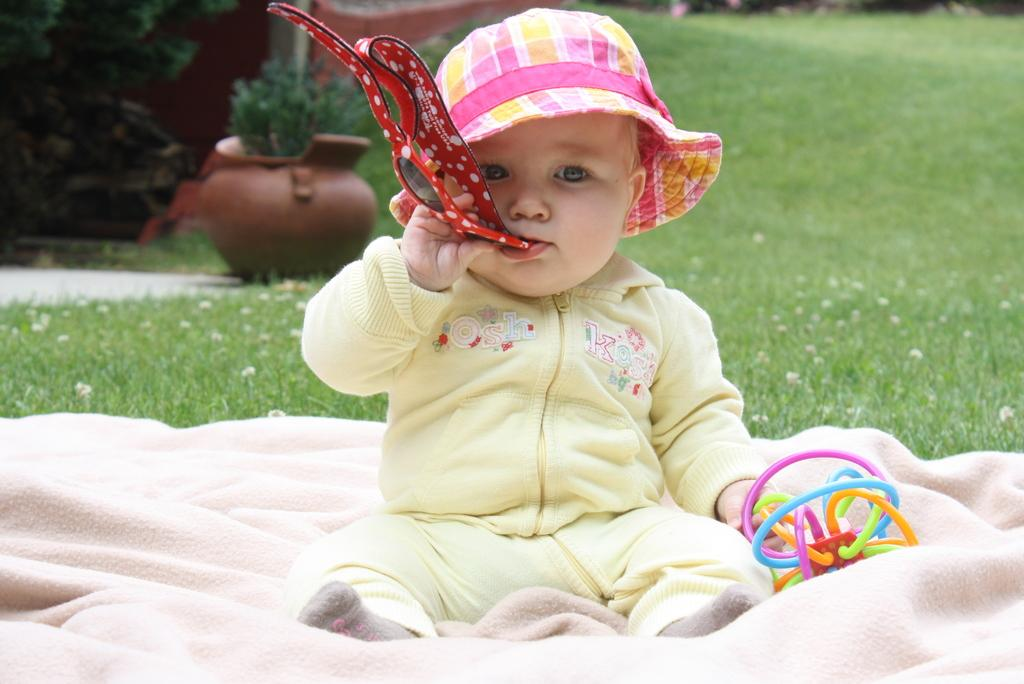What is the main subject of the image? The main subject of the image is a kid. What is the kid doing in the image? The kid is holding some objects and sitting on a cloth. What can be seen on the ground in the image? There is grass on the ground. What other object is visible in the image? There is a pot in the image. What color are the kid's eyes in the image? The provided facts do not mention the color of the kid's eyes, so we cannot determine that information from the image. 